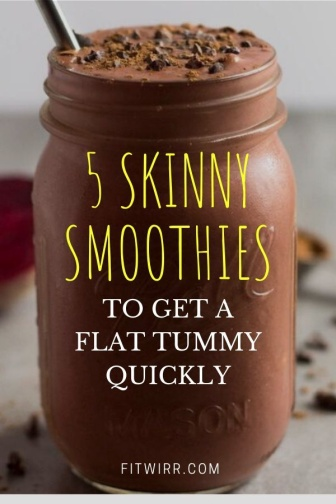What are some possible health benefits of ingredients typically found in smoothies like the one shown? A smoothie similar to the one depicted likely includes ingredients such as cocoa, which is rich in antioxidants that support heart and brain health. Dairy or plant-based milk offers calcium, vital for bone strength. If bananas are included, they provide potassium essential for muscle function and nerve transmission. These ingredients not only enhance flavor but also contribute to an individual's overall nutritional intake. 